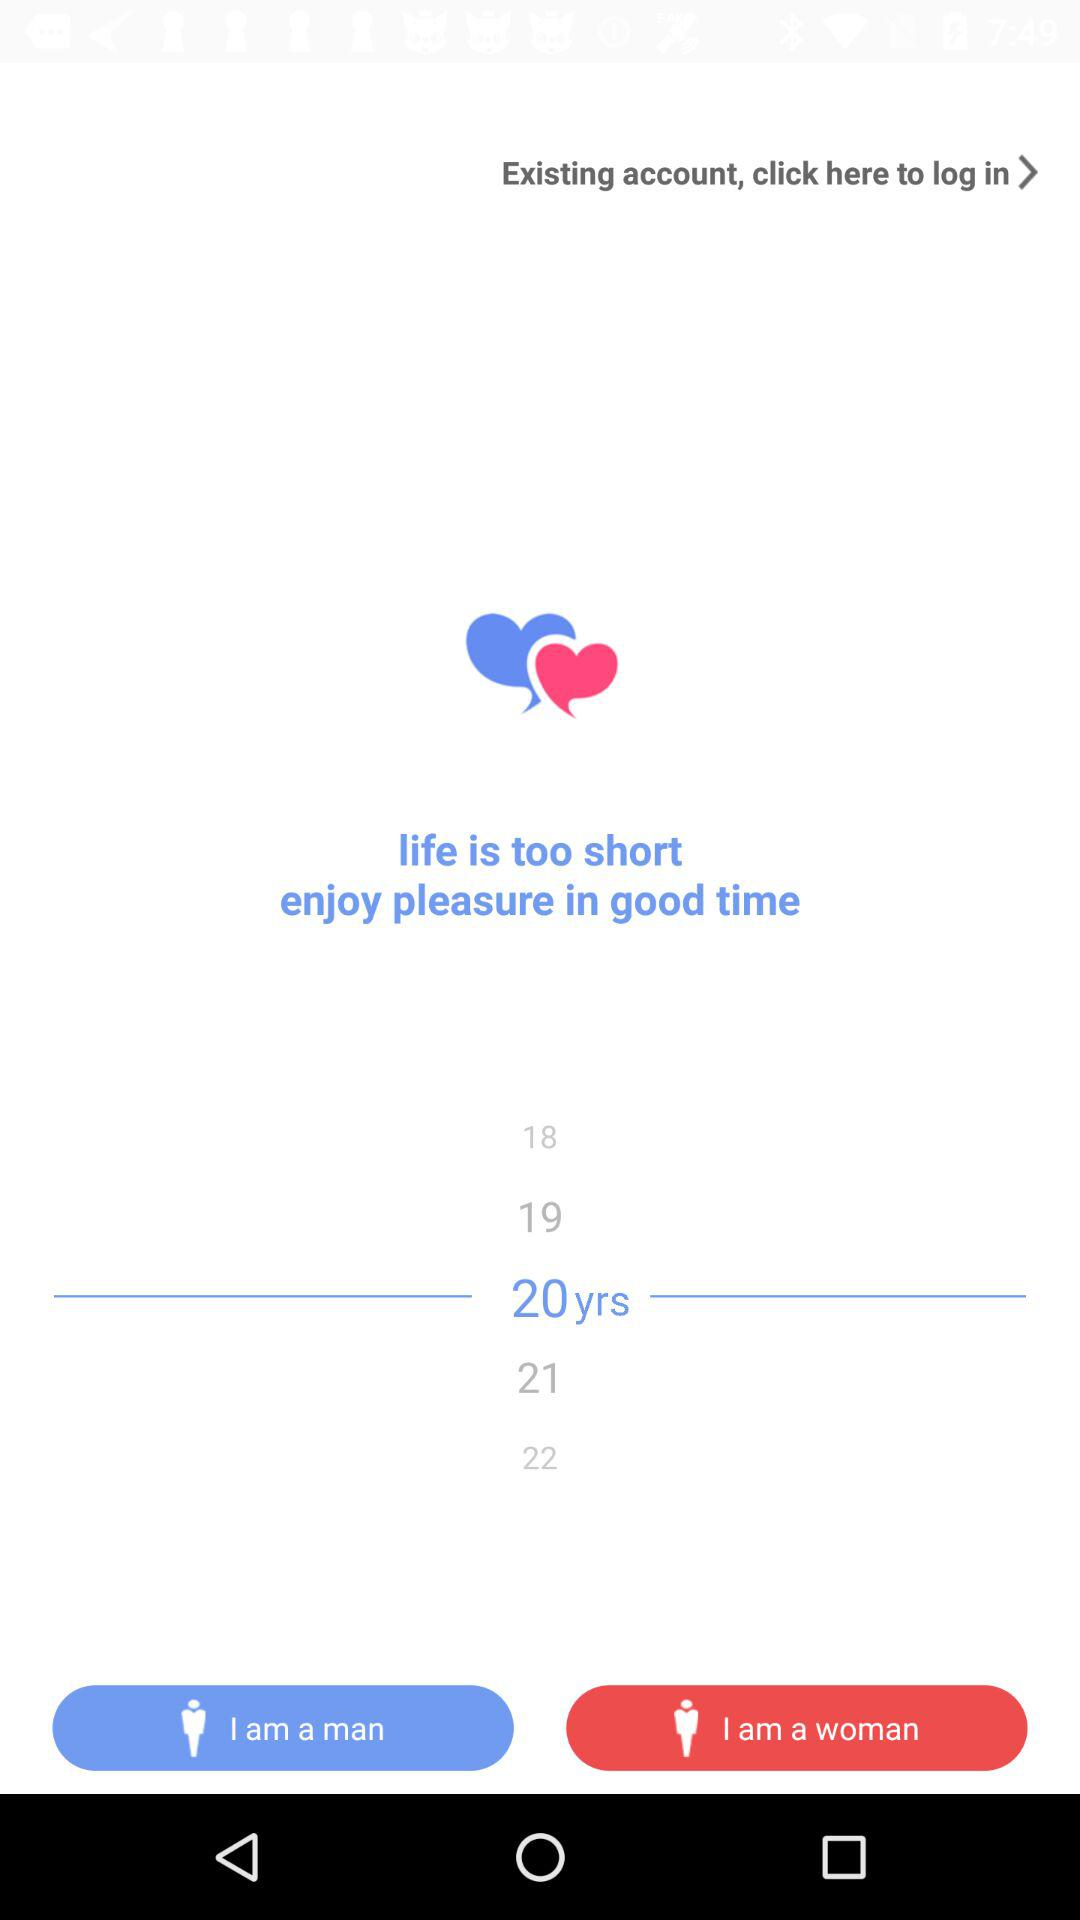How many years older is the oldest age option than the youngest?
Answer the question using a single word or phrase. 4 